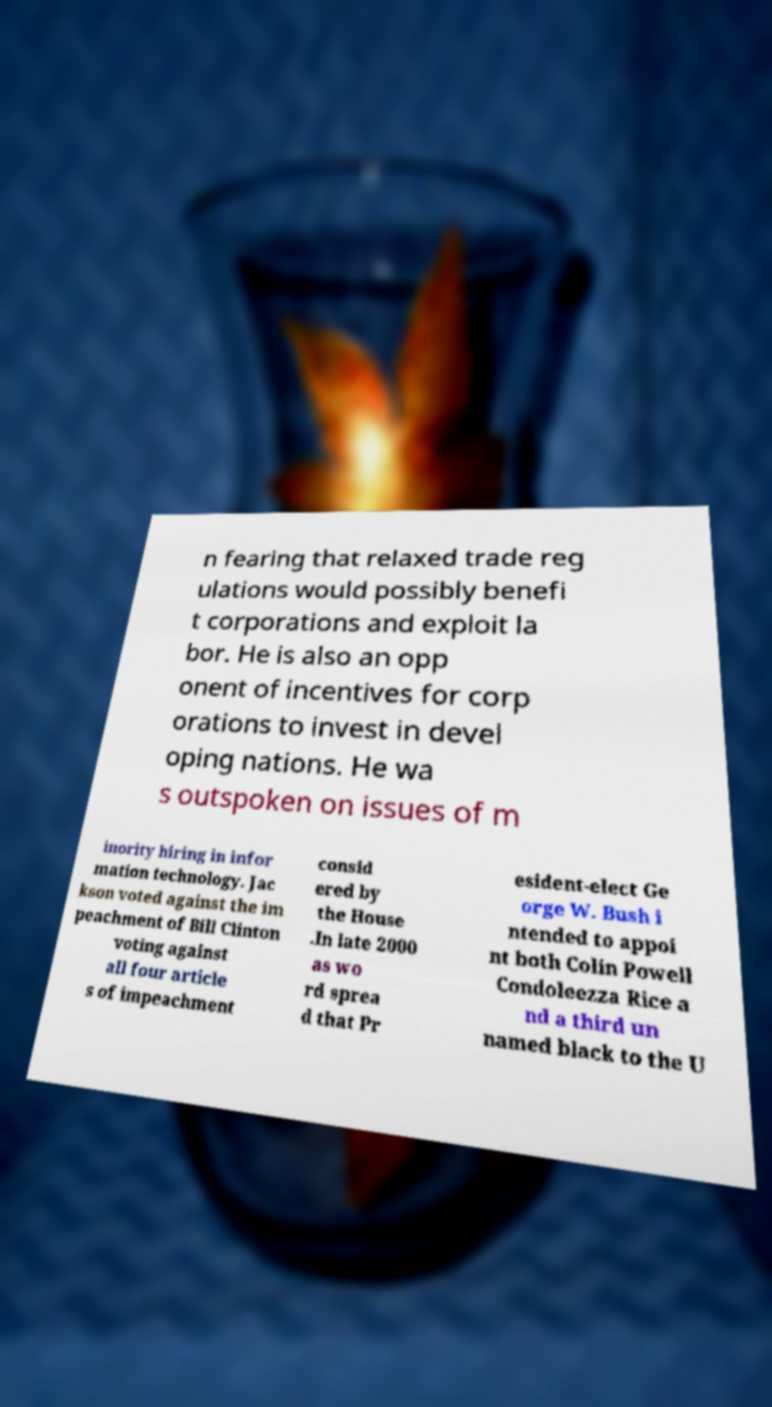Please read and relay the text visible in this image. What does it say? n fearing that relaxed trade reg ulations would possibly benefi t corporations and exploit la bor. He is also an opp onent of incentives for corp orations to invest in devel oping nations. He wa s outspoken on issues of m inority hiring in infor mation technology. Jac kson voted against the im peachment of Bill Clinton voting against all four article s of impeachment consid ered by the House .In late 2000 as wo rd sprea d that Pr esident-elect Ge orge W. Bush i ntended to appoi nt both Colin Powell Condoleezza Rice a nd a third un named black to the U 